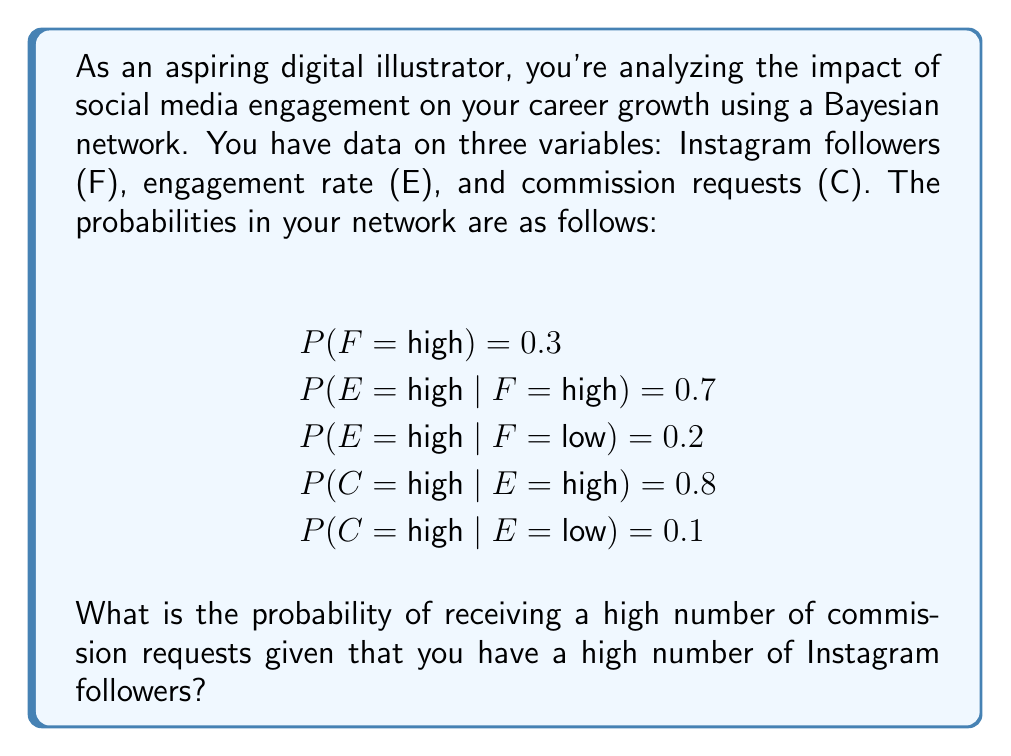Show me your answer to this math problem. To solve this problem, we need to use Bayes' theorem and the concept of marginalization. Let's break it down step by step:

1. We want to find P(C = high | F = high).

2. We can use the law of total probability:

   $$P(C = high | F = high) = P(C = high | E = high, F = high) \cdot P(E = high | F = high) + P(C = high | E = low, F = high) \cdot P(E = low | F = high)$$

3. From the given information:
   - P(E = high | F = high) = 0.7
   - P(E = low | F = high) = 1 - 0.7 = 0.3
   - P(C = high | E = high) = 0.8
   - P(C = high | E = low) = 0.1

4. Note that P(C = high | E = high, F = high) = P(C = high | E = high) because C is conditionally independent of F given E in this Bayesian network.

5. Substituting the values:

   $$P(C = high | F = high) = 0.8 \cdot 0.7 + 0.1 \cdot 0.3$$

6. Calculating:

   $$P(C = high | F = high) = 0.56 + 0.03 = 0.59$$

Therefore, the probability of receiving a high number of commission requests given that you have a high number of Instagram followers is 0.59 or 59%.
Answer: 0.59 or 59% 